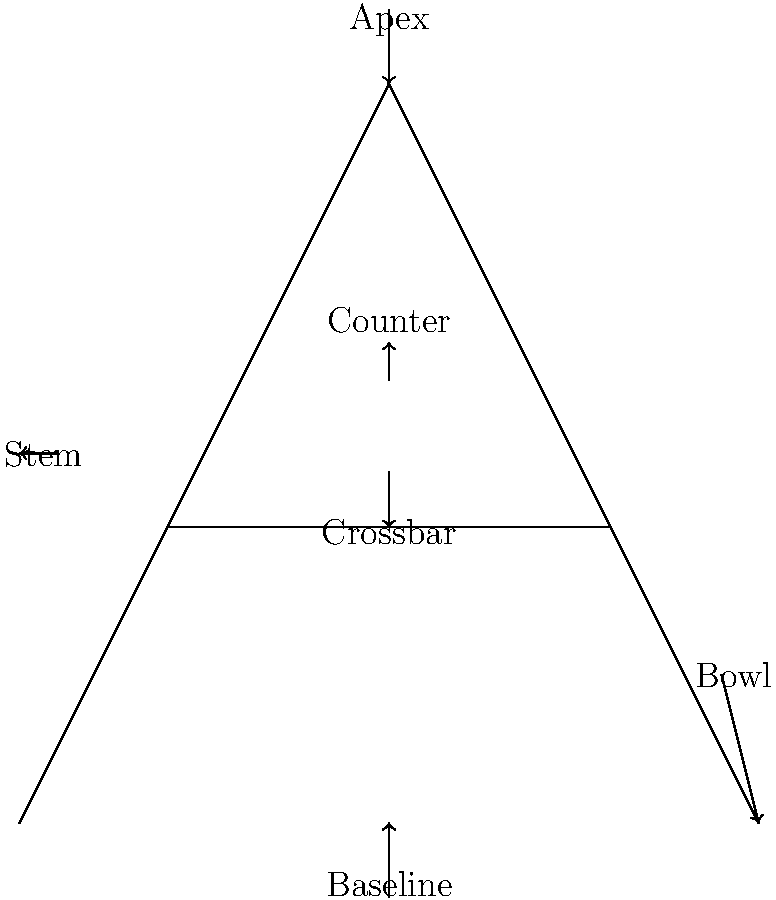In the given diagram of the letter 'A', which part is labeled as the "Counter"? To answer this question, let's break down the anatomy of the letter 'A' as shown in the diagram:

1. The Apex is the topmost point of the letter, where the two stems meet.
2. The Stems are the two diagonal lines that form the main structure of the 'A'.
3. The Crossbar is the horizontal line that connects the two stems.
4. The Bowl is the curved part at the bottom of the right stem.
5. The Baseline is the invisible line on which the letter sits.
6. The Counter is the enclosed or partially enclosed space within a letter.

In this diagram of the letter 'A', the Counter is the triangular space above the Crossbar and below the Apex. It's labeled and pointed to by an arrow in the upper middle part of the letter.

As a designer, understanding typeface anatomy is crucial for creating and manipulating fonts effectively. The Counter is an important element in typography as it affects the readability and overall appearance of a letter or font.
Answer: The enclosed triangular space above the Crossbar 